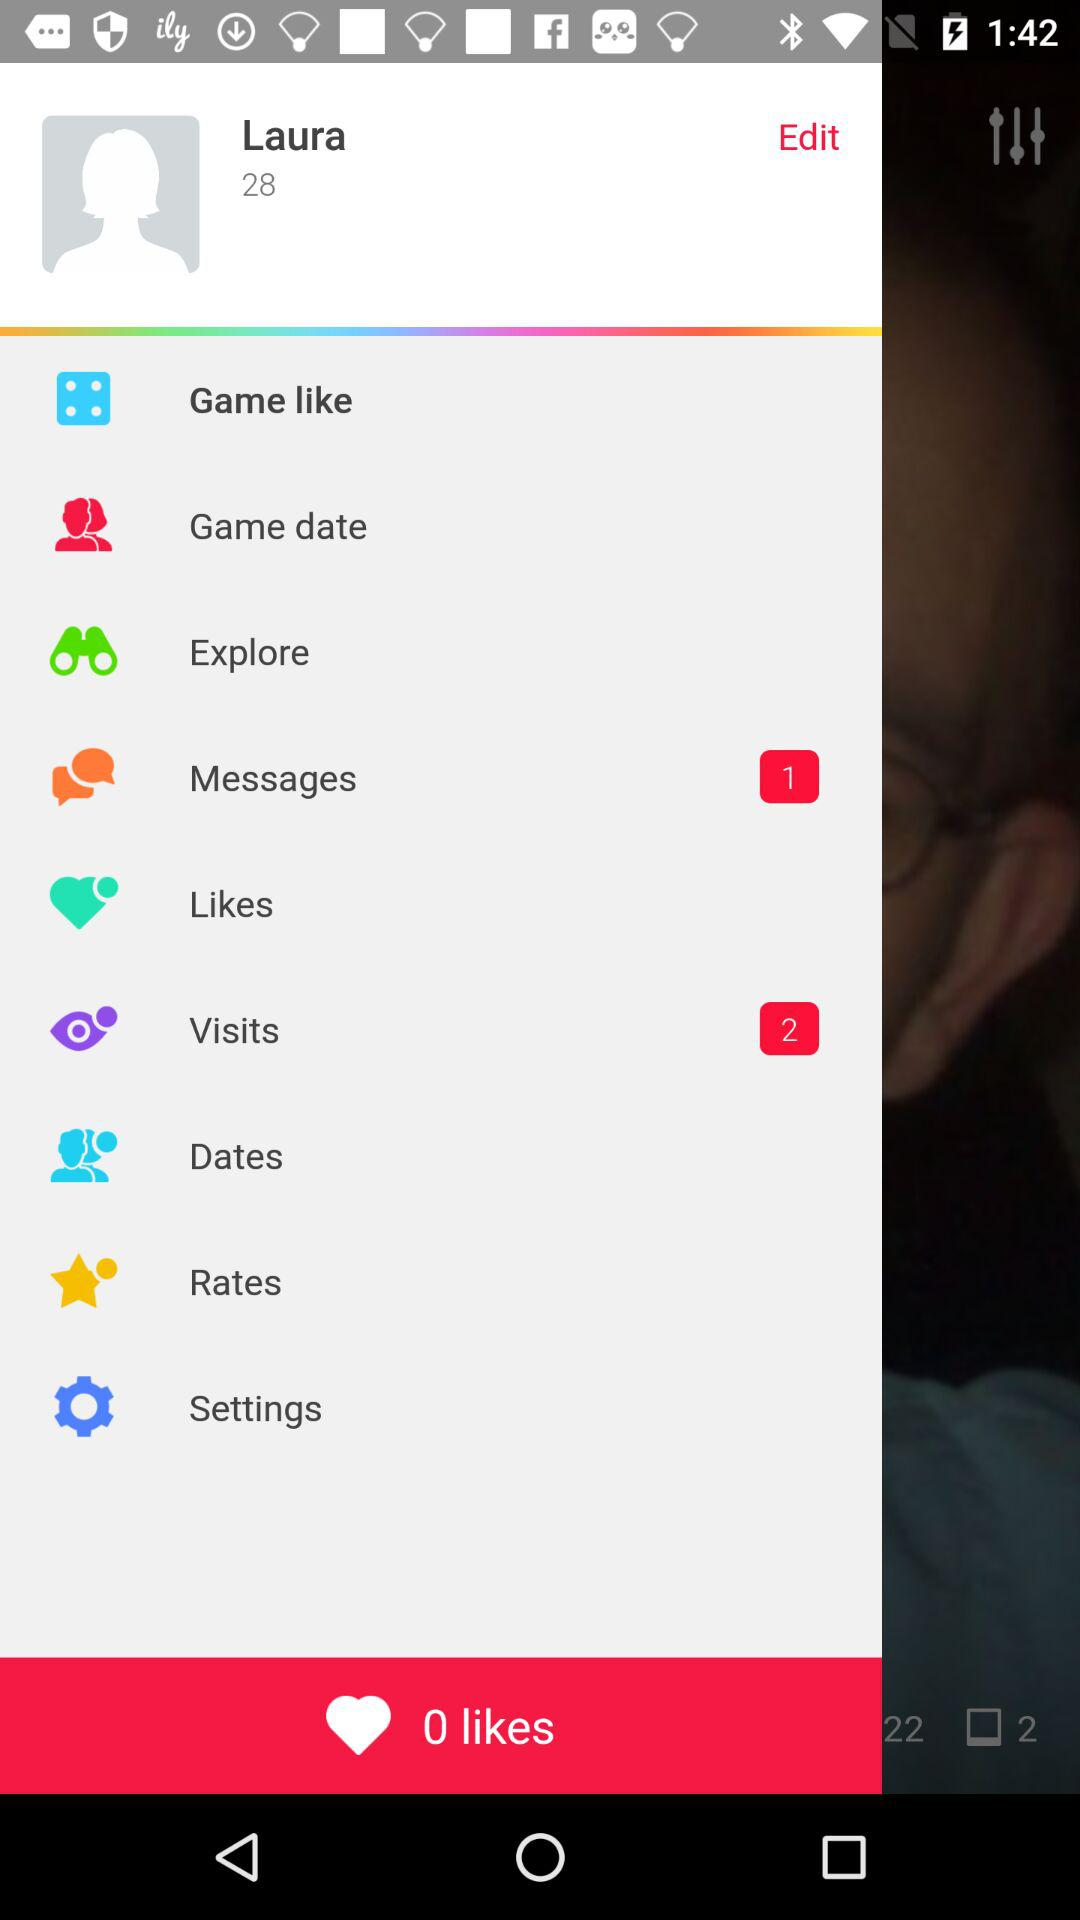How many more messages does Laura have than likes?
Answer the question using a single word or phrase. 1 